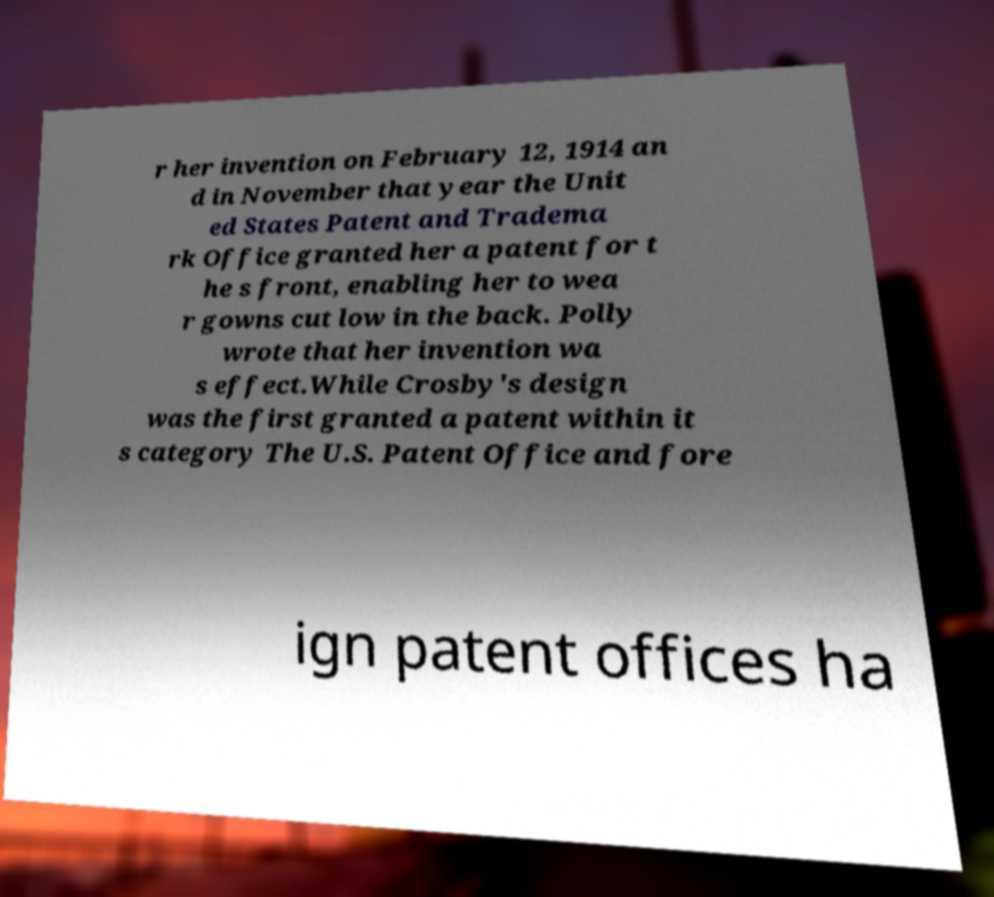Please identify and transcribe the text found in this image. r her invention on February 12, 1914 an d in November that year the Unit ed States Patent and Tradema rk Office granted her a patent for t he s front, enabling her to wea r gowns cut low in the back. Polly wrote that her invention wa s effect.While Crosby's design was the first granted a patent within it s category The U.S. Patent Office and fore ign patent offices ha 